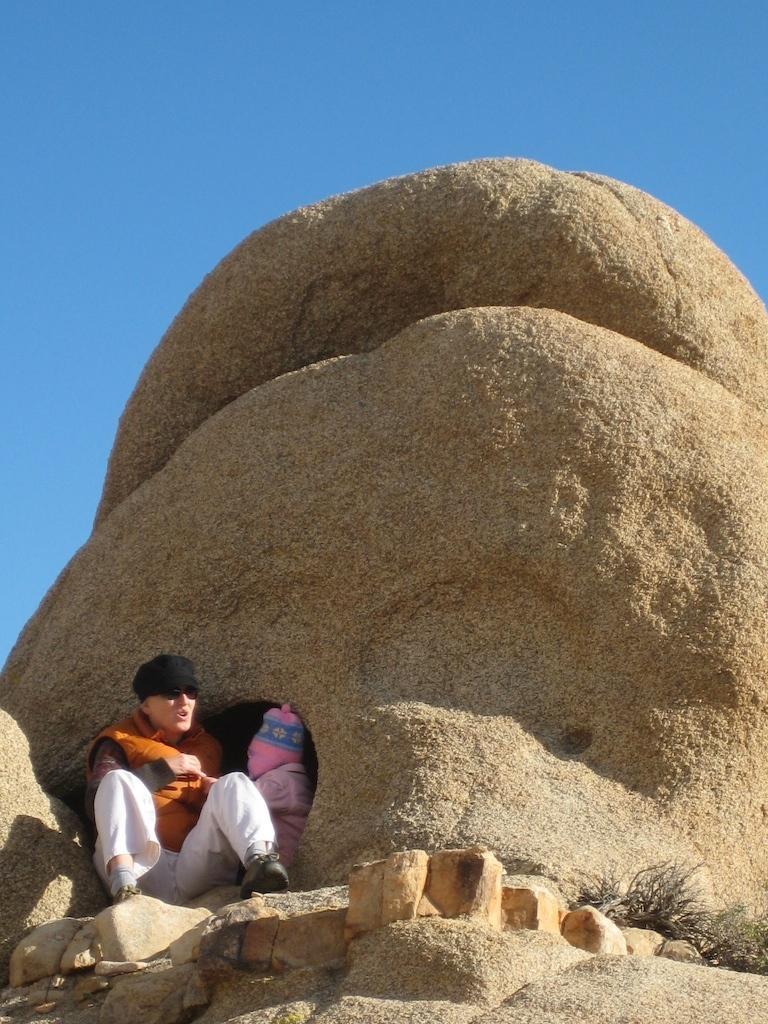How would you summarize this image in a sentence or two? In this picture I can see two persons on the left side, in the middle it looks like a rock. In the background I can see the sky. 